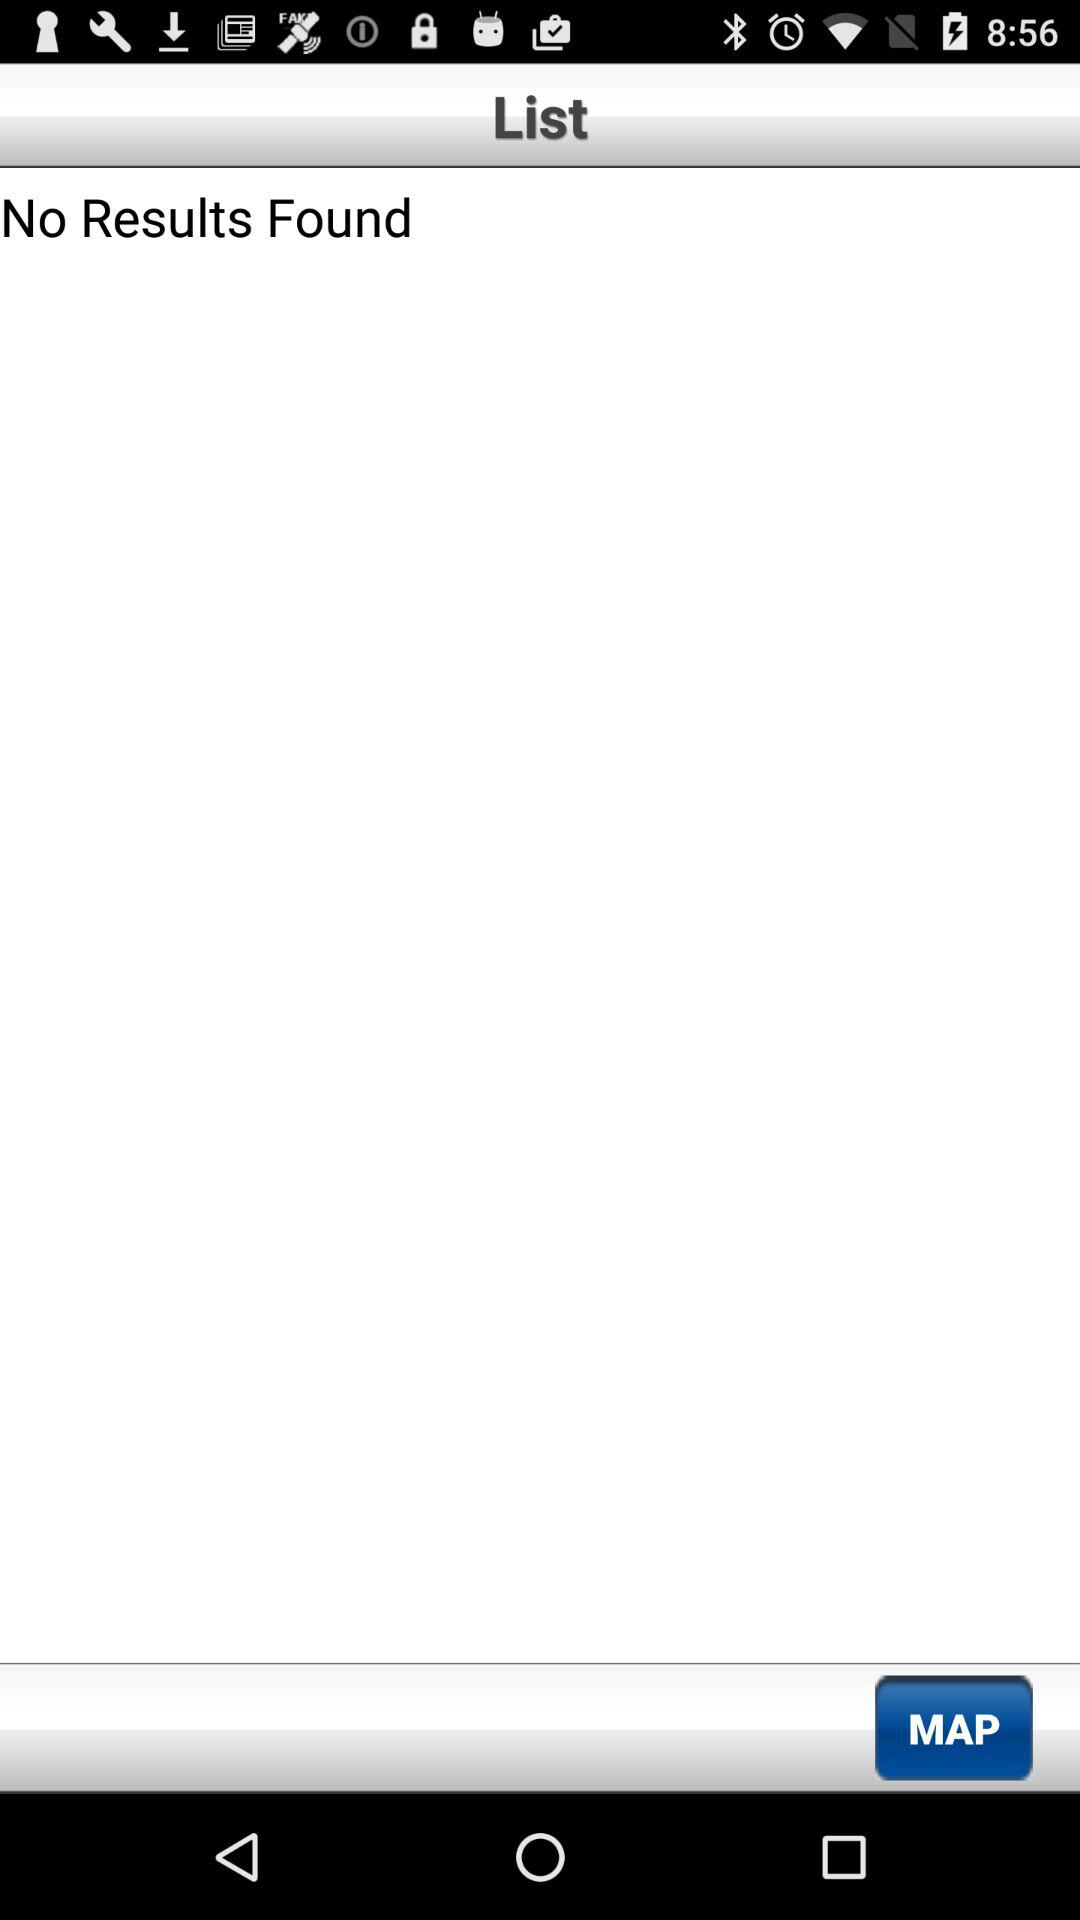Is there any result? There is no result. 